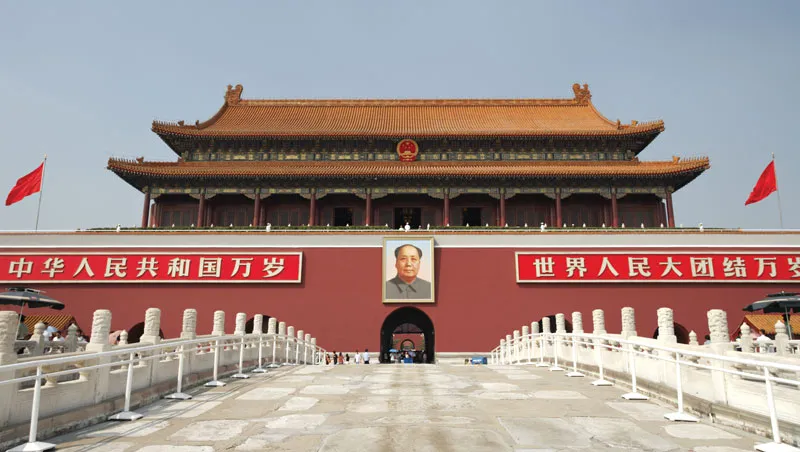What do you see happening in this image? The image portrays the grand Tiananmen Gate, also known as the Gate of Heavenly Peace, a prominent symbol located at the north end of Tiananmen Square in Beijing, China. This majestic gate, painted in an eye-catching red, contrasts with the gleaming golden roofs that catch the sunlight, creating a striking visual against the blue sky. At the center, a large portrait of Mao Zedong overlooks the square, symbolizing his enduring influence on Chinese politics and society. Flanking the portrait are two vibrant red flags, symbolizing the People's Republic of China. The image, taken from a frontal perspective, captures the gate’s imposing architecture and cultural significance, allowing the viewer to appreciate its historical importance and architectural beauty. Additional details such as the meticulous stonework of the balustrades and the imposing size of the gate provide a sense of scale and the meticulous planning behind its construction. 